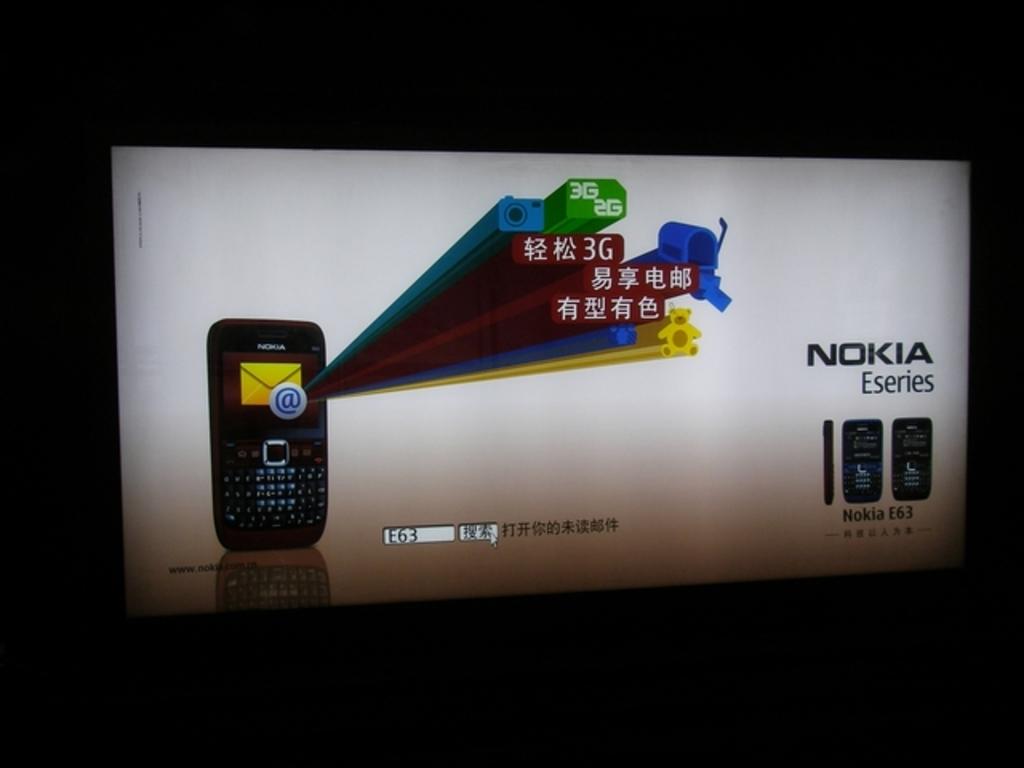What brand of phone is advertised here?
Your response must be concise. Nokia. 